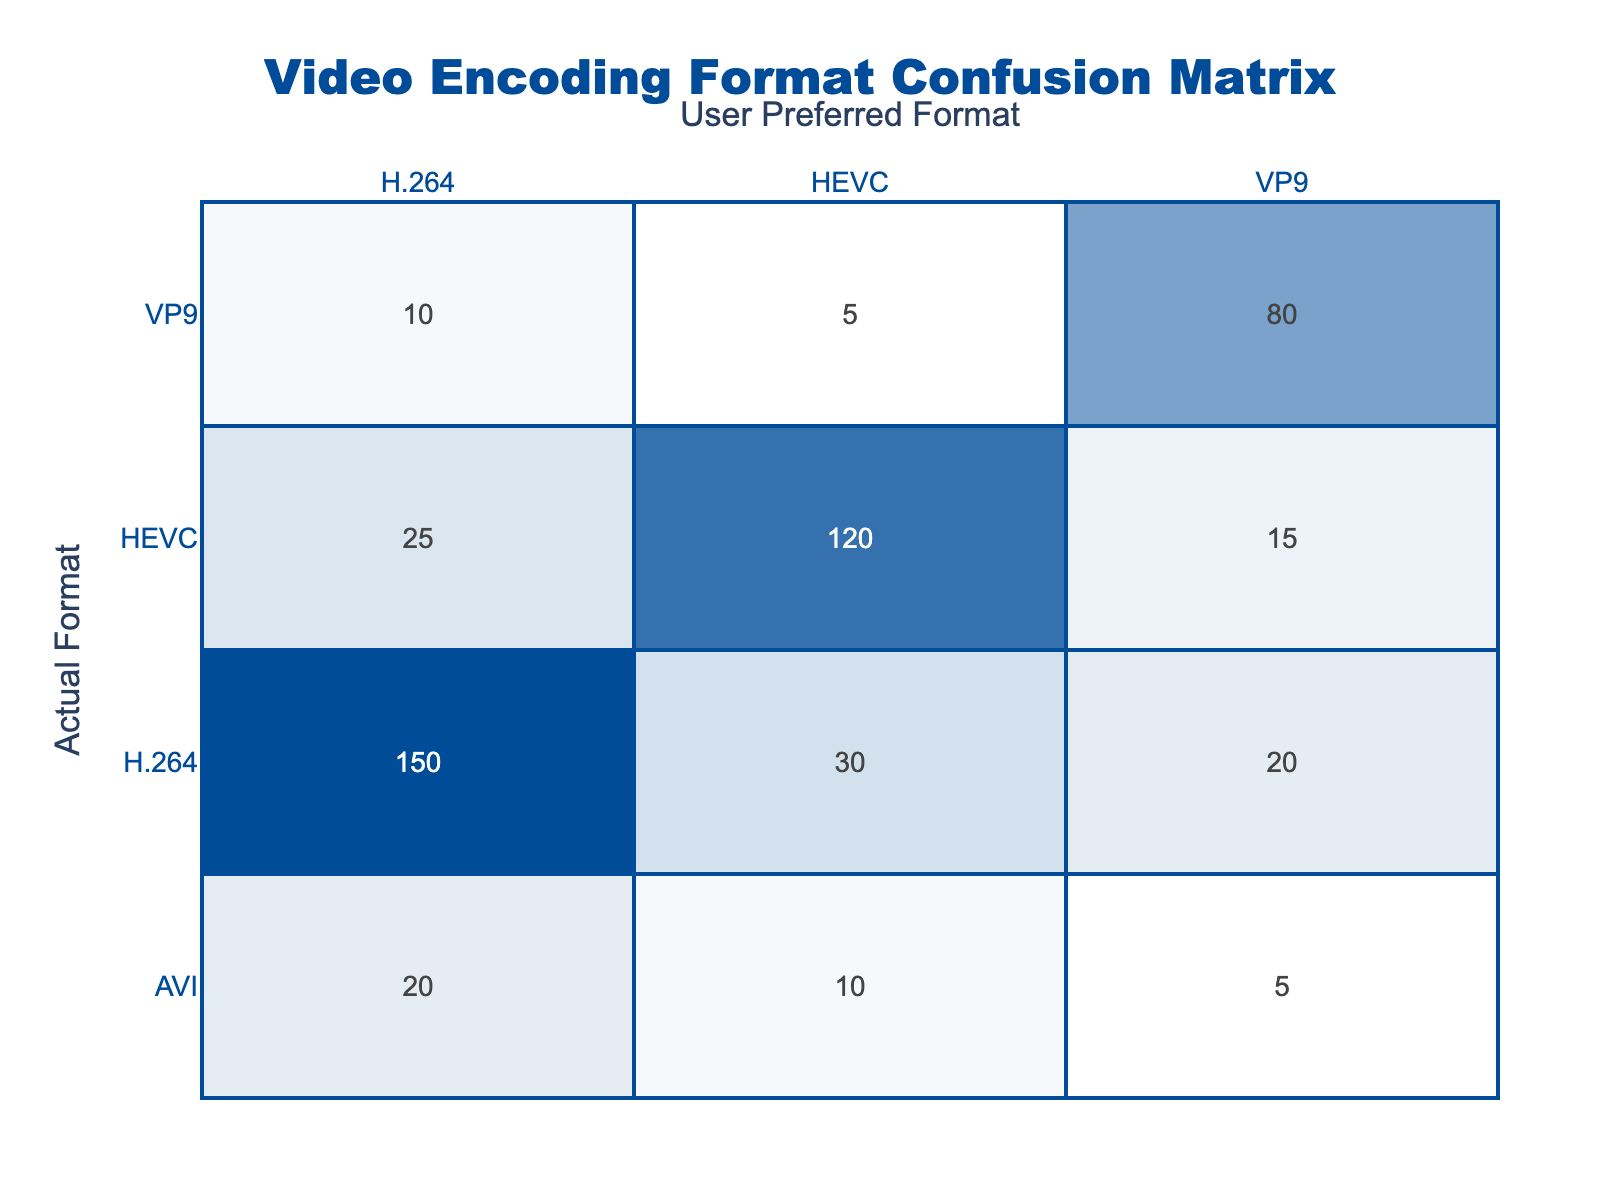What is the total number of users who preferred H.264 as the actual format? To find the total number of users who preferred H.264 as the actual format, we sum the counts for all the rows where the Actual Format is H.264. These are: 150 (H.264, H.264) + 30 (H.264, HEVC) + 20 (H.264, VP9) = 200.
Answer: 200 How many users preferred HEVC when the actual format was HEVC? According to the table, the number of users who preferred HEVC when the actual format was HEVC is directly given in the corresponding cell, which is 120.
Answer: 120 What is the total count of users who preferred VP9 across all actual formats? We can find the total number of users who preferred VP9 by adding the counts from the rows where the User Preferred Format is VP9: 20 (H.264, VP9) + 15 (HEVC, VP9) + 80 (VP9, VP9) + 5 (AVI, VP9) = 120.
Answer: 120 Did more users prefer HEVC over H.264 when the actual format was VP9? For the actual format of VP9, the counts show 10 users preferred H.264 and 5 users preferred HEVC. Since 10 is greater than 5, the statement is false.
Answer: No What is the difference in the number of users who preferred H.264 when the actual format was H.264 compared to when it was AVI? We compare the counts: 150 users preferred H.264 (when actual format is H.264) and 20 users preferred H.264 (when actual format is AVI). The difference is 150 - 20 = 130.
Answer: 130 Which actual format had the least number of users preferring it when it was VP9? By examining the counts for the actual format of VP9, we see that the counts are: 10 (H.264), 5 (HEVC), and 80 (VP9). The least is 5 users preferring HEVC.
Answer: HEVC What percentage of users preferred H.264 over all actual formats? To find the percentage of users who preferred H.264, we first need the total number of counts from the table: 150 + 30 + 20 + 25 + 120 + 15 + 10 + 5 + 80 + 20 + 10 + 5 = 470. The count for H.264 as any preferred format: 150 + 30 + 20 + 20 = 220. The percentage is (220/470) * 100 ≈ 46.81%.
Answer: 46.81% How many users preferred formats other than VP9 when the actual format was VP9? We sum the counts for the actual format of VP9, subtracting the count for VP9 itself: 10 (H.264) + 5 (HEVC) = 15 users preferred formats other than VP9.
Answer: 15 Did any users prefer AVI as their actual format and also preferred H.264? Looking at the table, we see 20 users preferred H.264 when AVI was the actual format. Therefore, the answer is yes.
Answer: Yes 